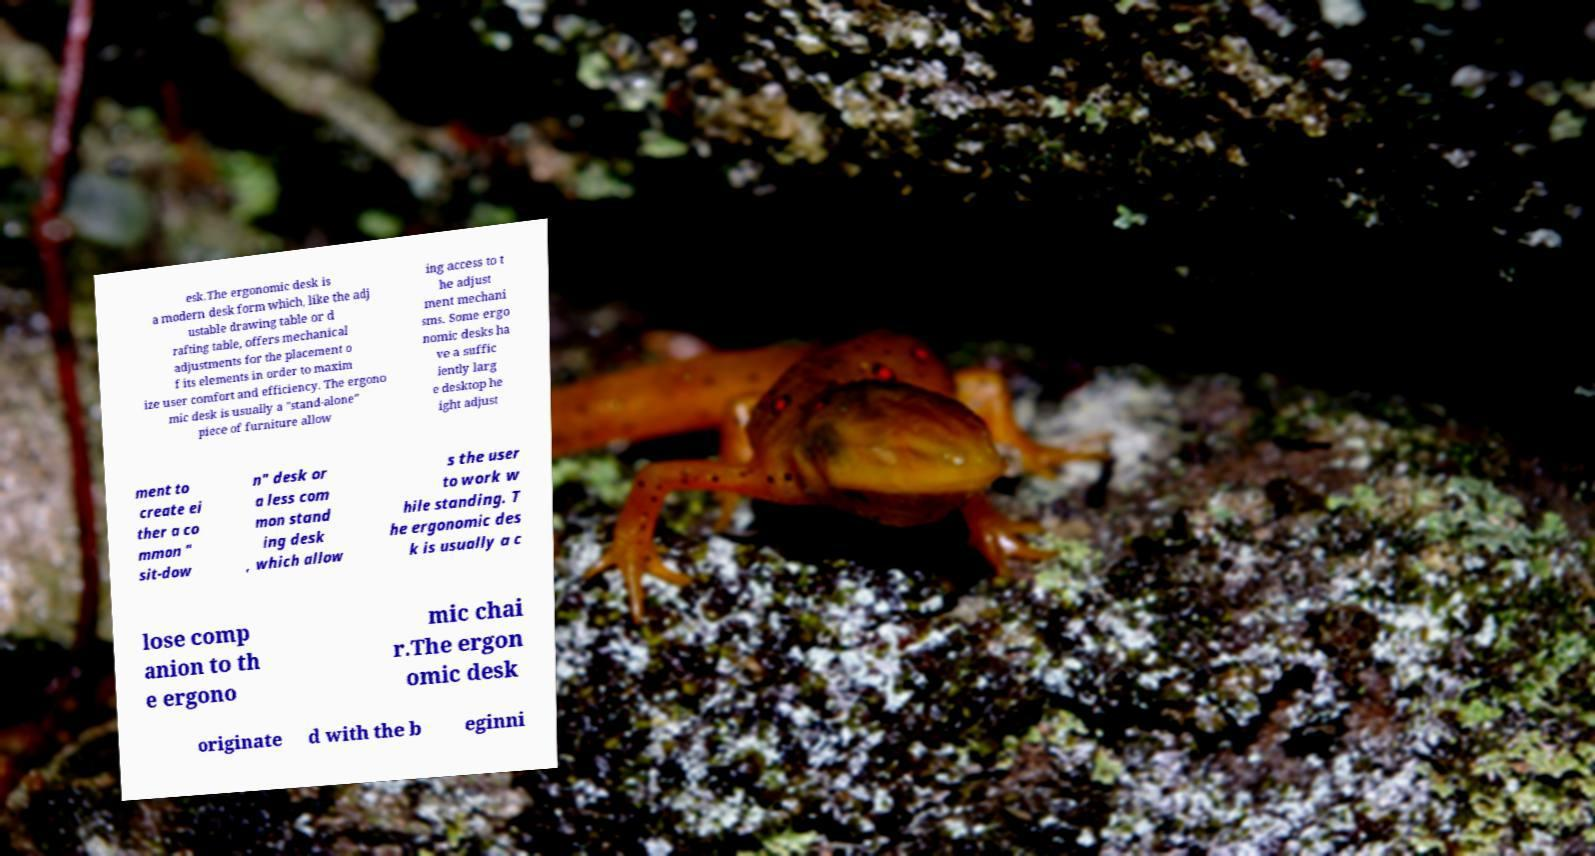For documentation purposes, I need the text within this image transcribed. Could you provide that? esk.The ergonomic desk is a modern desk form which, like the adj ustable drawing table or d rafting table, offers mechanical adjustments for the placement o f its elements in order to maxim ize user comfort and efficiency. The ergono mic desk is usually a "stand-alone" piece of furniture allow ing access to t he adjust ment mechani sms. Some ergo nomic desks ha ve a suffic iently larg e desktop he ight adjust ment to create ei ther a co mmon " sit-dow n" desk or a less com mon stand ing desk , which allow s the user to work w hile standing. T he ergonomic des k is usually a c lose comp anion to th e ergono mic chai r.The ergon omic desk originate d with the b eginni 